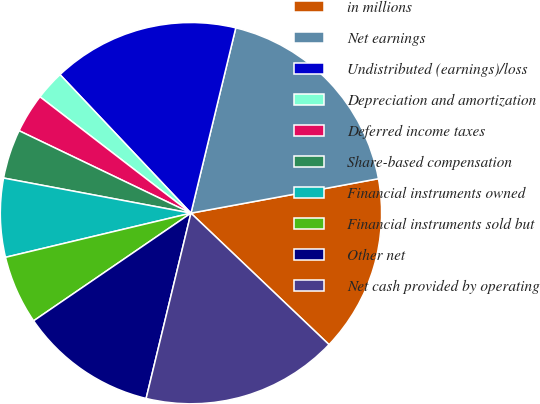Convert chart. <chart><loc_0><loc_0><loc_500><loc_500><pie_chart><fcel>in millions<fcel>Net earnings<fcel>Undistributed (earnings)/loss<fcel>Depreciation and amortization<fcel>Deferred income taxes<fcel>Share-based compensation<fcel>Financial instruments owned<fcel>Financial instruments sold but<fcel>Other net<fcel>Net cash provided by operating<nl><fcel>15.0%<fcel>18.33%<fcel>15.83%<fcel>2.5%<fcel>3.33%<fcel>4.17%<fcel>6.67%<fcel>5.83%<fcel>11.67%<fcel>16.67%<nl></chart> 